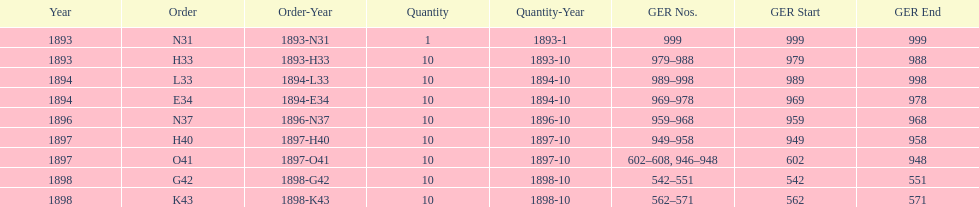Were there more n31 or e34 ordered? E34. 